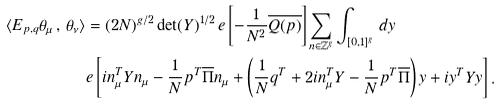Convert formula to latex. <formula><loc_0><loc_0><loc_500><loc_500>\langle E _ { p , q } \theta _ { \mu } \, , \, \theta _ { \nu } \rangle & = ( 2 N ) ^ { g / 2 } \det ( Y ) ^ { 1 / 2 } \, e \left [ - \frac { 1 } { N ^ { 2 } } \overline { Q ( p ) } \right ] \sum _ { n \in { \mathbb { Z } } ^ { g } } \int _ { [ 0 , 1 ] ^ { g } } \, d y \\ & e \left [ i n _ { \mu } ^ { T } Y n _ { \mu } - \frac { 1 } { N } p ^ { T } \overline { \Pi } n _ { \mu } + \left ( \frac { 1 } { N } q ^ { T } + 2 i n _ { \mu } ^ { T } Y - \frac { 1 } { N } p ^ { T } \overline { \Pi } \right ) y + i y ^ { T } Y y \right ] .</formula> 